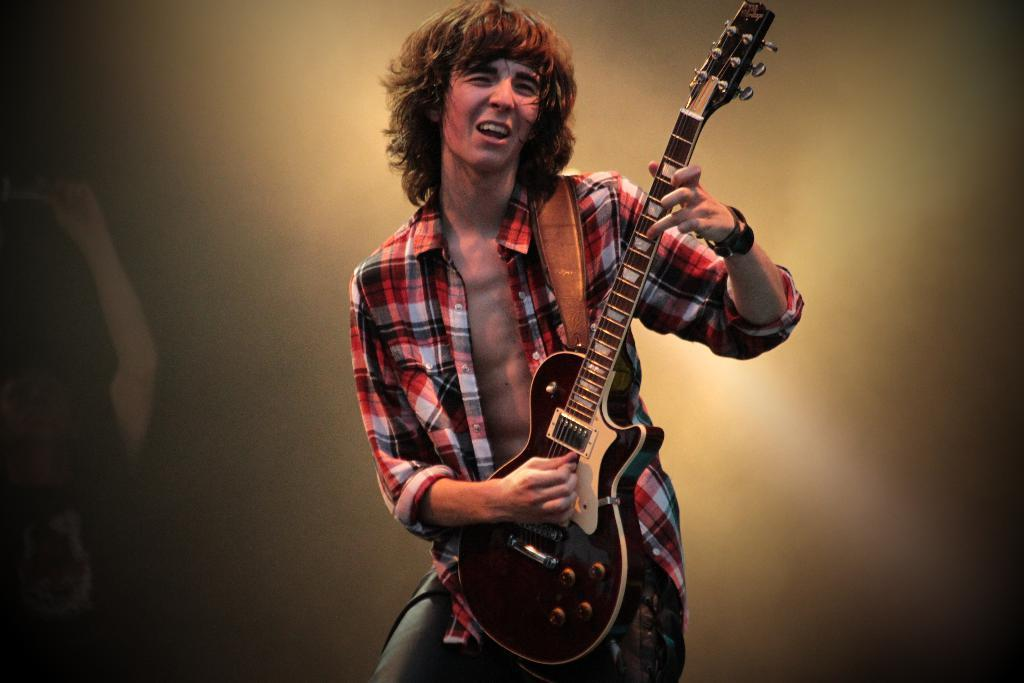What is the man in the image doing? The man is playing a guitar and singing. Can you describe the object to the left of the man? Unfortunately, the background of the image is blurry, so it is difficult to identify the object to the left of the man. What is the overall setting of the image? The man is playing a guitar and singing, and the background is blurry, suggesting a possible performance or informal setting. What type of pump is visible in the bedroom in the image? There is no pump or bedroom present in the image; it features a man playing a guitar and singing with a blurry background. 